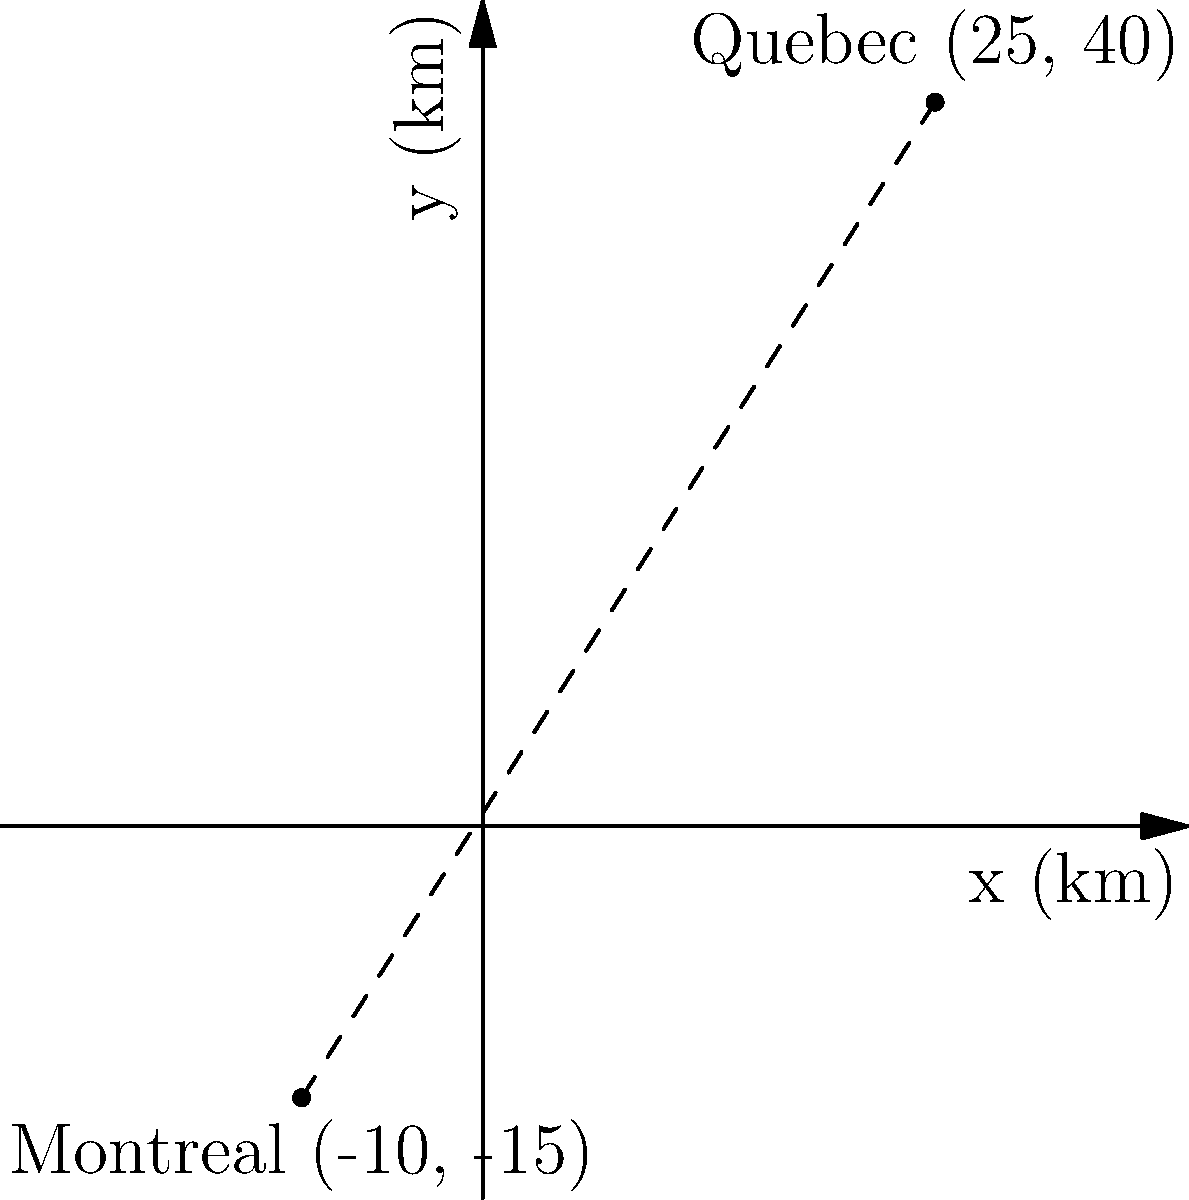In the early days of French colonization in North America, two important settlements were established: Quebec and Montreal. On a coordinate plane where each unit represents 1 km, Quebec is located at (25, 40) and Montreal at (-10, -15). Using the distance formula, calculate the straight-line distance between these two colonial settlements. Round your answer to the nearest kilometer. To solve this problem, we'll use the distance formula derived from the Pythagorean theorem:

$$d = \sqrt{(x_2 - x_1)^2 + (y_2 - y_1)^2}$$

Where $(x_1, y_1)$ represents the coordinates of the first point (Quebec) and $(x_2, y_2)$ represents the coordinates of the second point (Montreal).

Step 1: Identify the coordinates
Quebec: $(x_1, y_1) = (25, 40)$
Montreal: $(x_2, y_2) = (-10, -15)$

Step 2: Plug the coordinates into the distance formula
$$d = \sqrt{(-10 - 25)^2 + (-15 - 40)^2}$$

Step 3: Simplify the expressions inside the parentheses
$$d = \sqrt{(-35)^2 + (-55)^2}$$

Step 4: Calculate the squares
$$d = \sqrt{1225 + 3025}$$

Step 5: Add the values under the square root
$$d = \sqrt{4250}$$

Step 6: Calculate the square root and round to the nearest kilometer
$$d \approx 65.19 \text{ km} \approx 65 \text{ km}$$

Therefore, the straight-line distance between Quebec and Montreal is approximately 65 km.
Answer: 65 km 